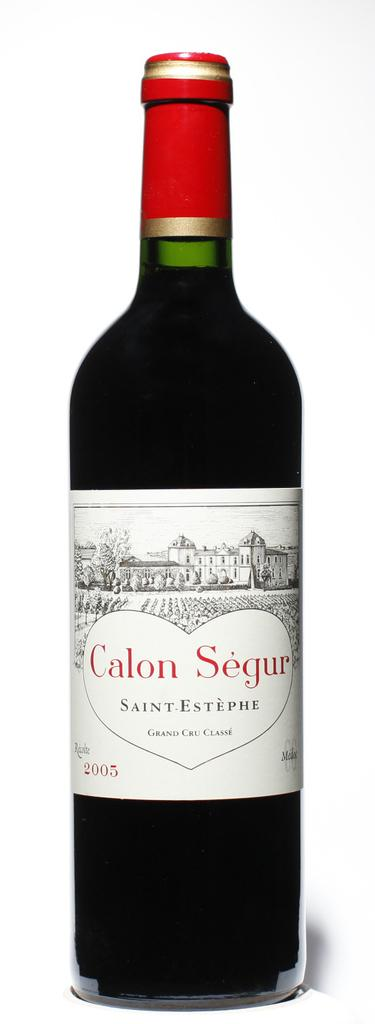<image>
Render a clear and concise summary of the photo. A bottle of Calon Segur has a white label with a long field in front of a very large house. 